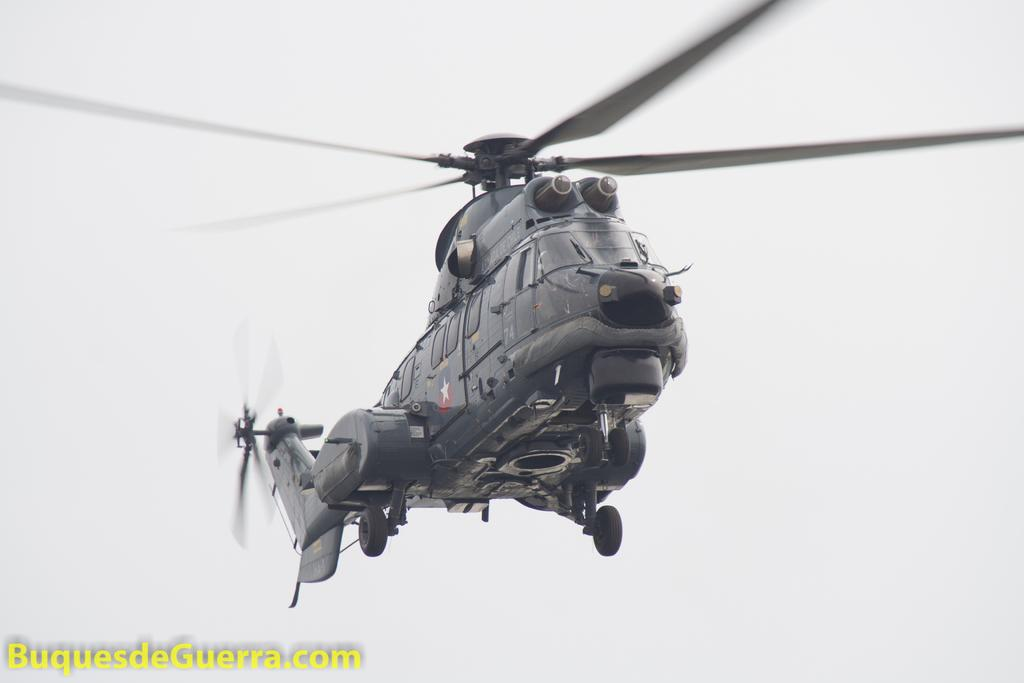What type of vehicle is in the image? There is a military helicopter in the image. What is the helicopter doing in the image? The helicopter is flying in the air. Is there any text present in the image? Yes, there is a small quote written on the bottom left side of the image. What type of polish is being applied to the helicopter in the image? There is no polish or application process visible in the image; it only shows a military helicopter flying in the air. 